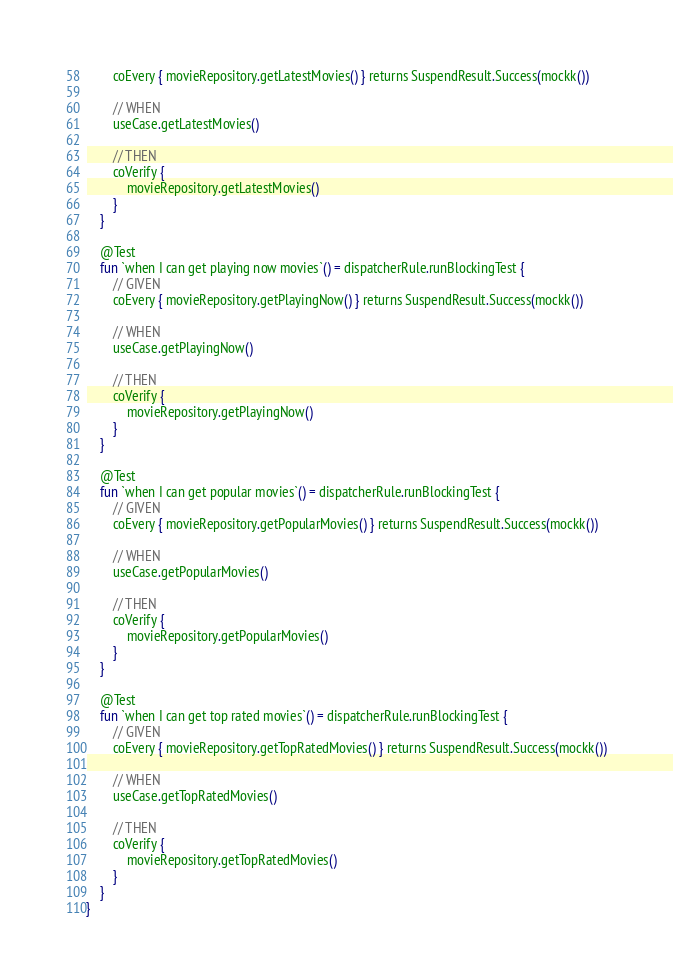<code> <loc_0><loc_0><loc_500><loc_500><_Kotlin_>        coEvery { movieRepository.getLatestMovies() } returns SuspendResult.Success(mockk())

        // WHEN
        useCase.getLatestMovies()

        // THEN
        coVerify {
            movieRepository.getLatestMovies()
        }
    }

    @Test
    fun `when I can get playing now movies`() = dispatcherRule.runBlockingTest {
        // GIVEN
        coEvery { movieRepository.getPlayingNow() } returns SuspendResult.Success(mockk())

        // WHEN
        useCase.getPlayingNow()

        // THEN
        coVerify {
            movieRepository.getPlayingNow()
        }
    }

    @Test
    fun `when I can get popular movies`() = dispatcherRule.runBlockingTest {
        // GIVEN
        coEvery { movieRepository.getPopularMovies() } returns SuspendResult.Success(mockk())

        // WHEN
        useCase.getPopularMovies()

        // THEN
        coVerify {
            movieRepository.getPopularMovies()
        }
    }

    @Test
    fun `when I can get top rated movies`() = dispatcherRule.runBlockingTest {
        // GIVEN
        coEvery { movieRepository.getTopRatedMovies() } returns SuspendResult.Success(mockk())

        // WHEN
        useCase.getTopRatedMovies()

        // THEN
        coVerify {
            movieRepository.getTopRatedMovies()
        }
    }
}</code> 